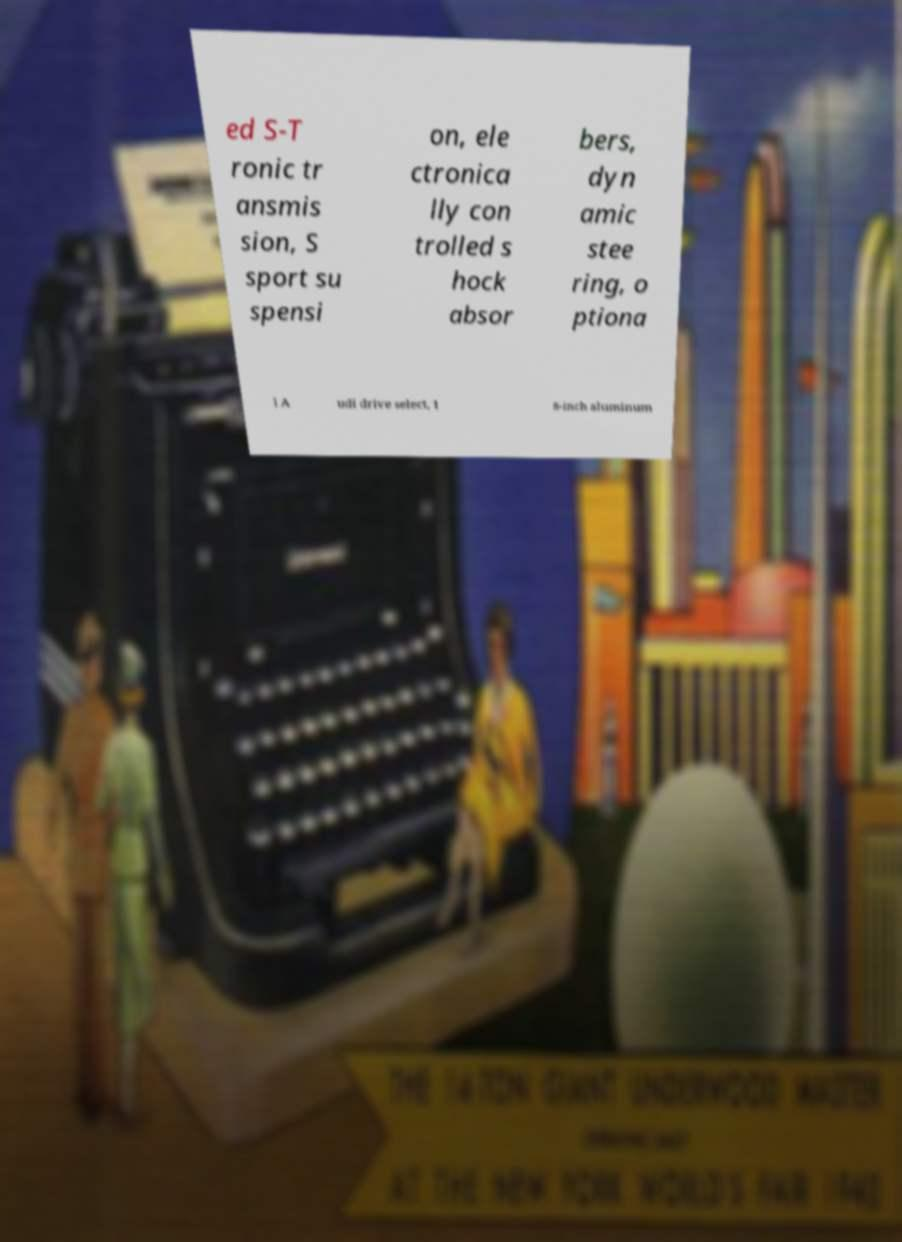There's text embedded in this image that I need extracted. Can you transcribe it verbatim? ed S-T ronic tr ansmis sion, S sport su spensi on, ele ctronica lly con trolled s hock absor bers, dyn amic stee ring, o ptiona l A udi drive select, 1 8-inch aluminum 